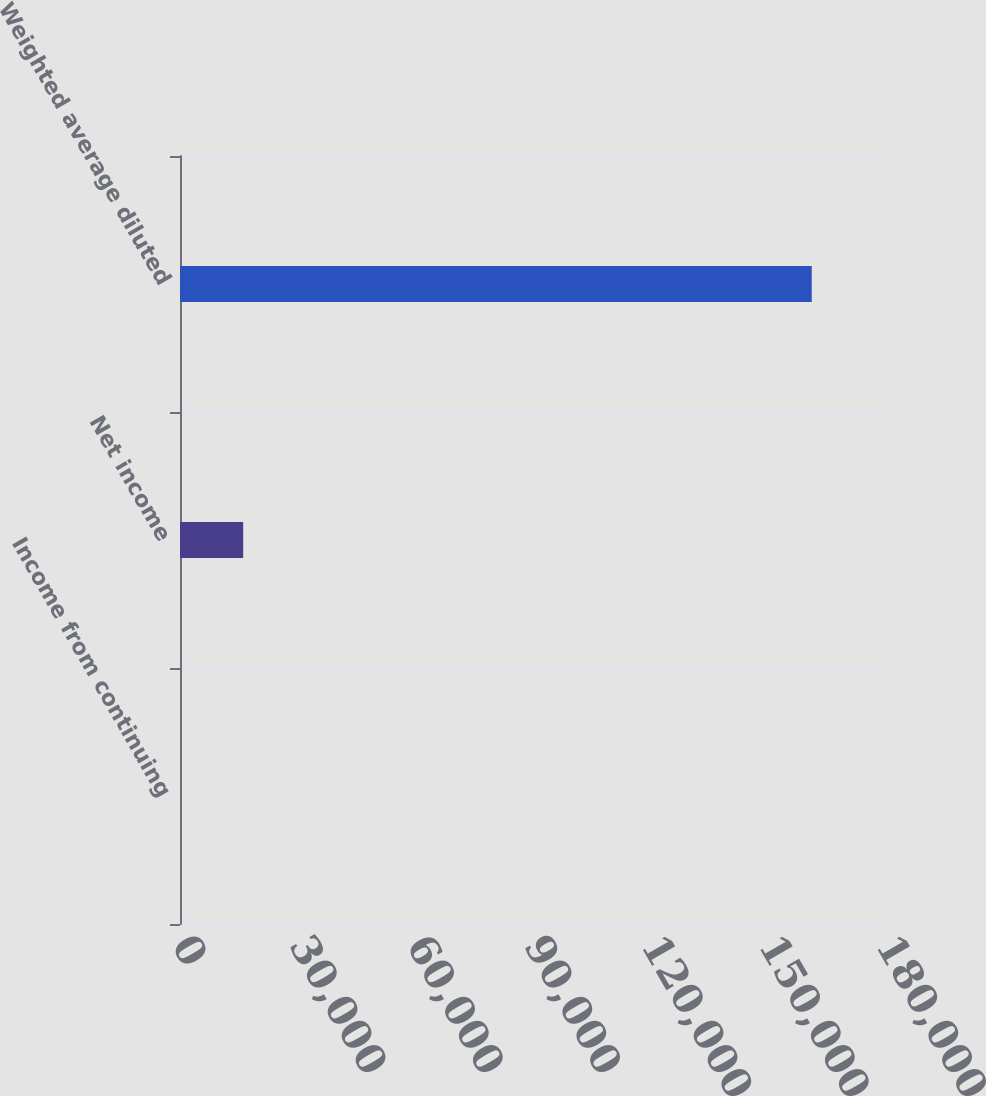Convert chart. <chart><loc_0><loc_0><loc_500><loc_500><bar_chart><fcel>Income from continuing<fcel>Net income<fcel>Weighted average diluted<nl><fcel>0.89<fcel>16152.8<fcel>161520<nl></chart> 